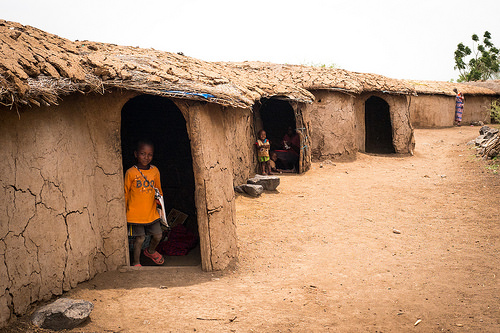<image>
Is there a boy in front of the hut? No. The boy is not in front of the hut. The spatial positioning shows a different relationship between these objects. 